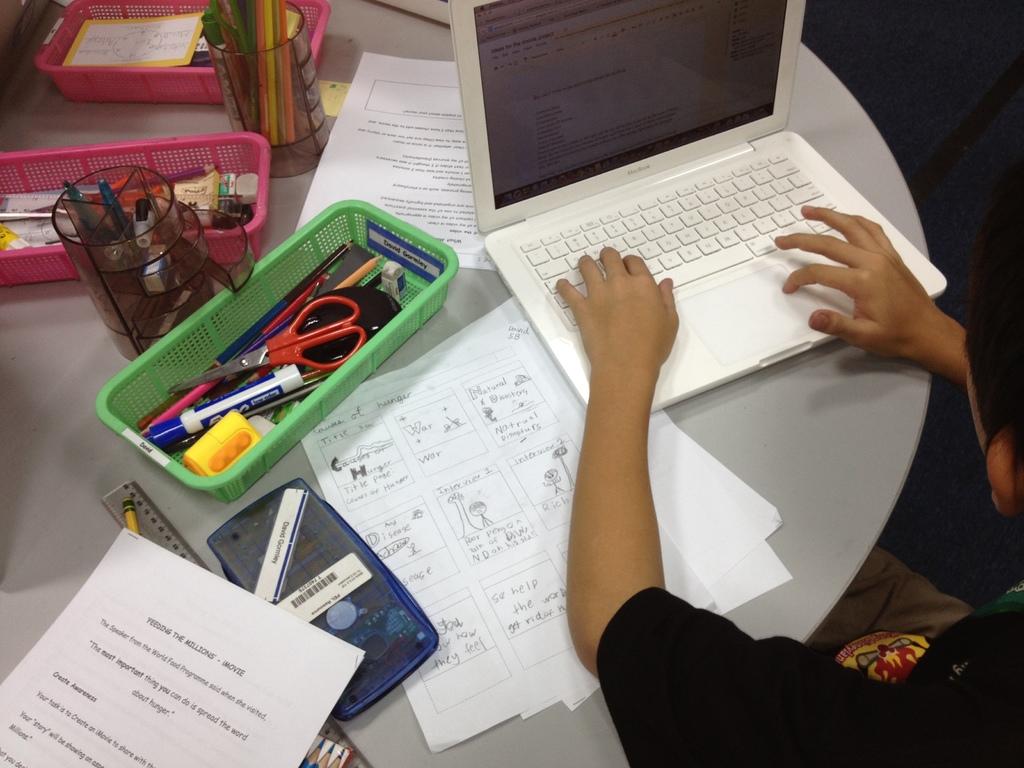What type of laptop is that?
Make the answer very short. Macbook. 